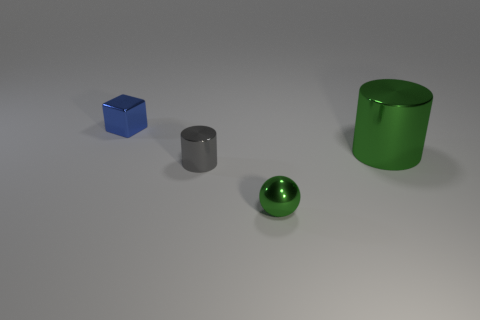Does the large cylinder have the same color as the small sphere?
Keep it short and to the point. Yes. There is a gray object; what shape is it?
Your response must be concise. Cylinder. What number of matte things are either small blue blocks or green things?
Offer a very short reply. 0. There is a shiny thing that is to the left of the small gray cylinder; how big is it?
Offer a terse response. Small. The ball that is made of the same material as the green cylinder is what size?
Provide a short and direct response. Small. How many small metallic objects are the same color as the small metallic cylinder?
Keep it short and to the point. 0. Are there any small cylinders?
Your response must be concise. Yes. Do the tiny blue thing and the object in front of the gray object have the same shape?
Provide a succinct answer. No. There is a cylinder on the right side of the green shiny thing on the left side of the green object behind the tiny green sphere; what is its color?
Make the answer very short. Green. Are there any objects in front of the big thing?
Keep it short and to the point. Yes. 